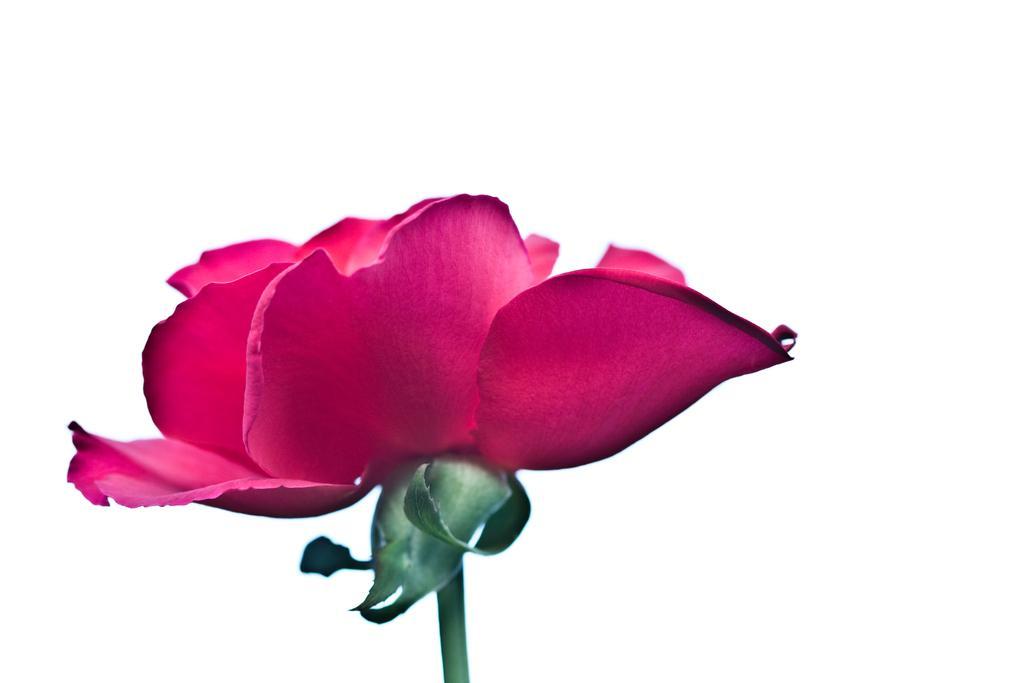In one or two sentences, can you explain what this image depicts? In the middle of the image there is a beautiful pink colored rose flower. 